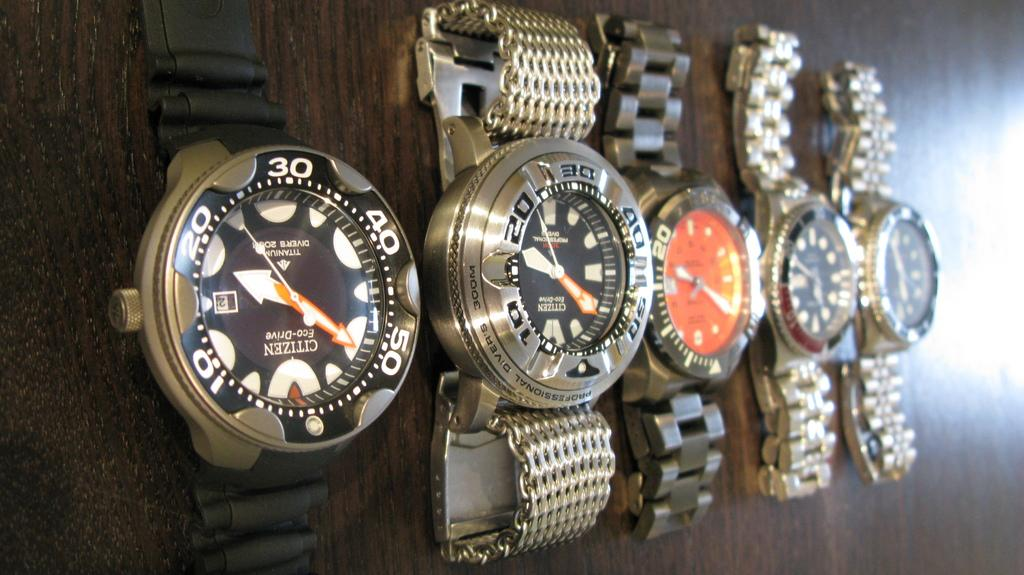<image>
Present a compact description of the photo's key features. Four watches are on a table and say "citizen" on the face. 